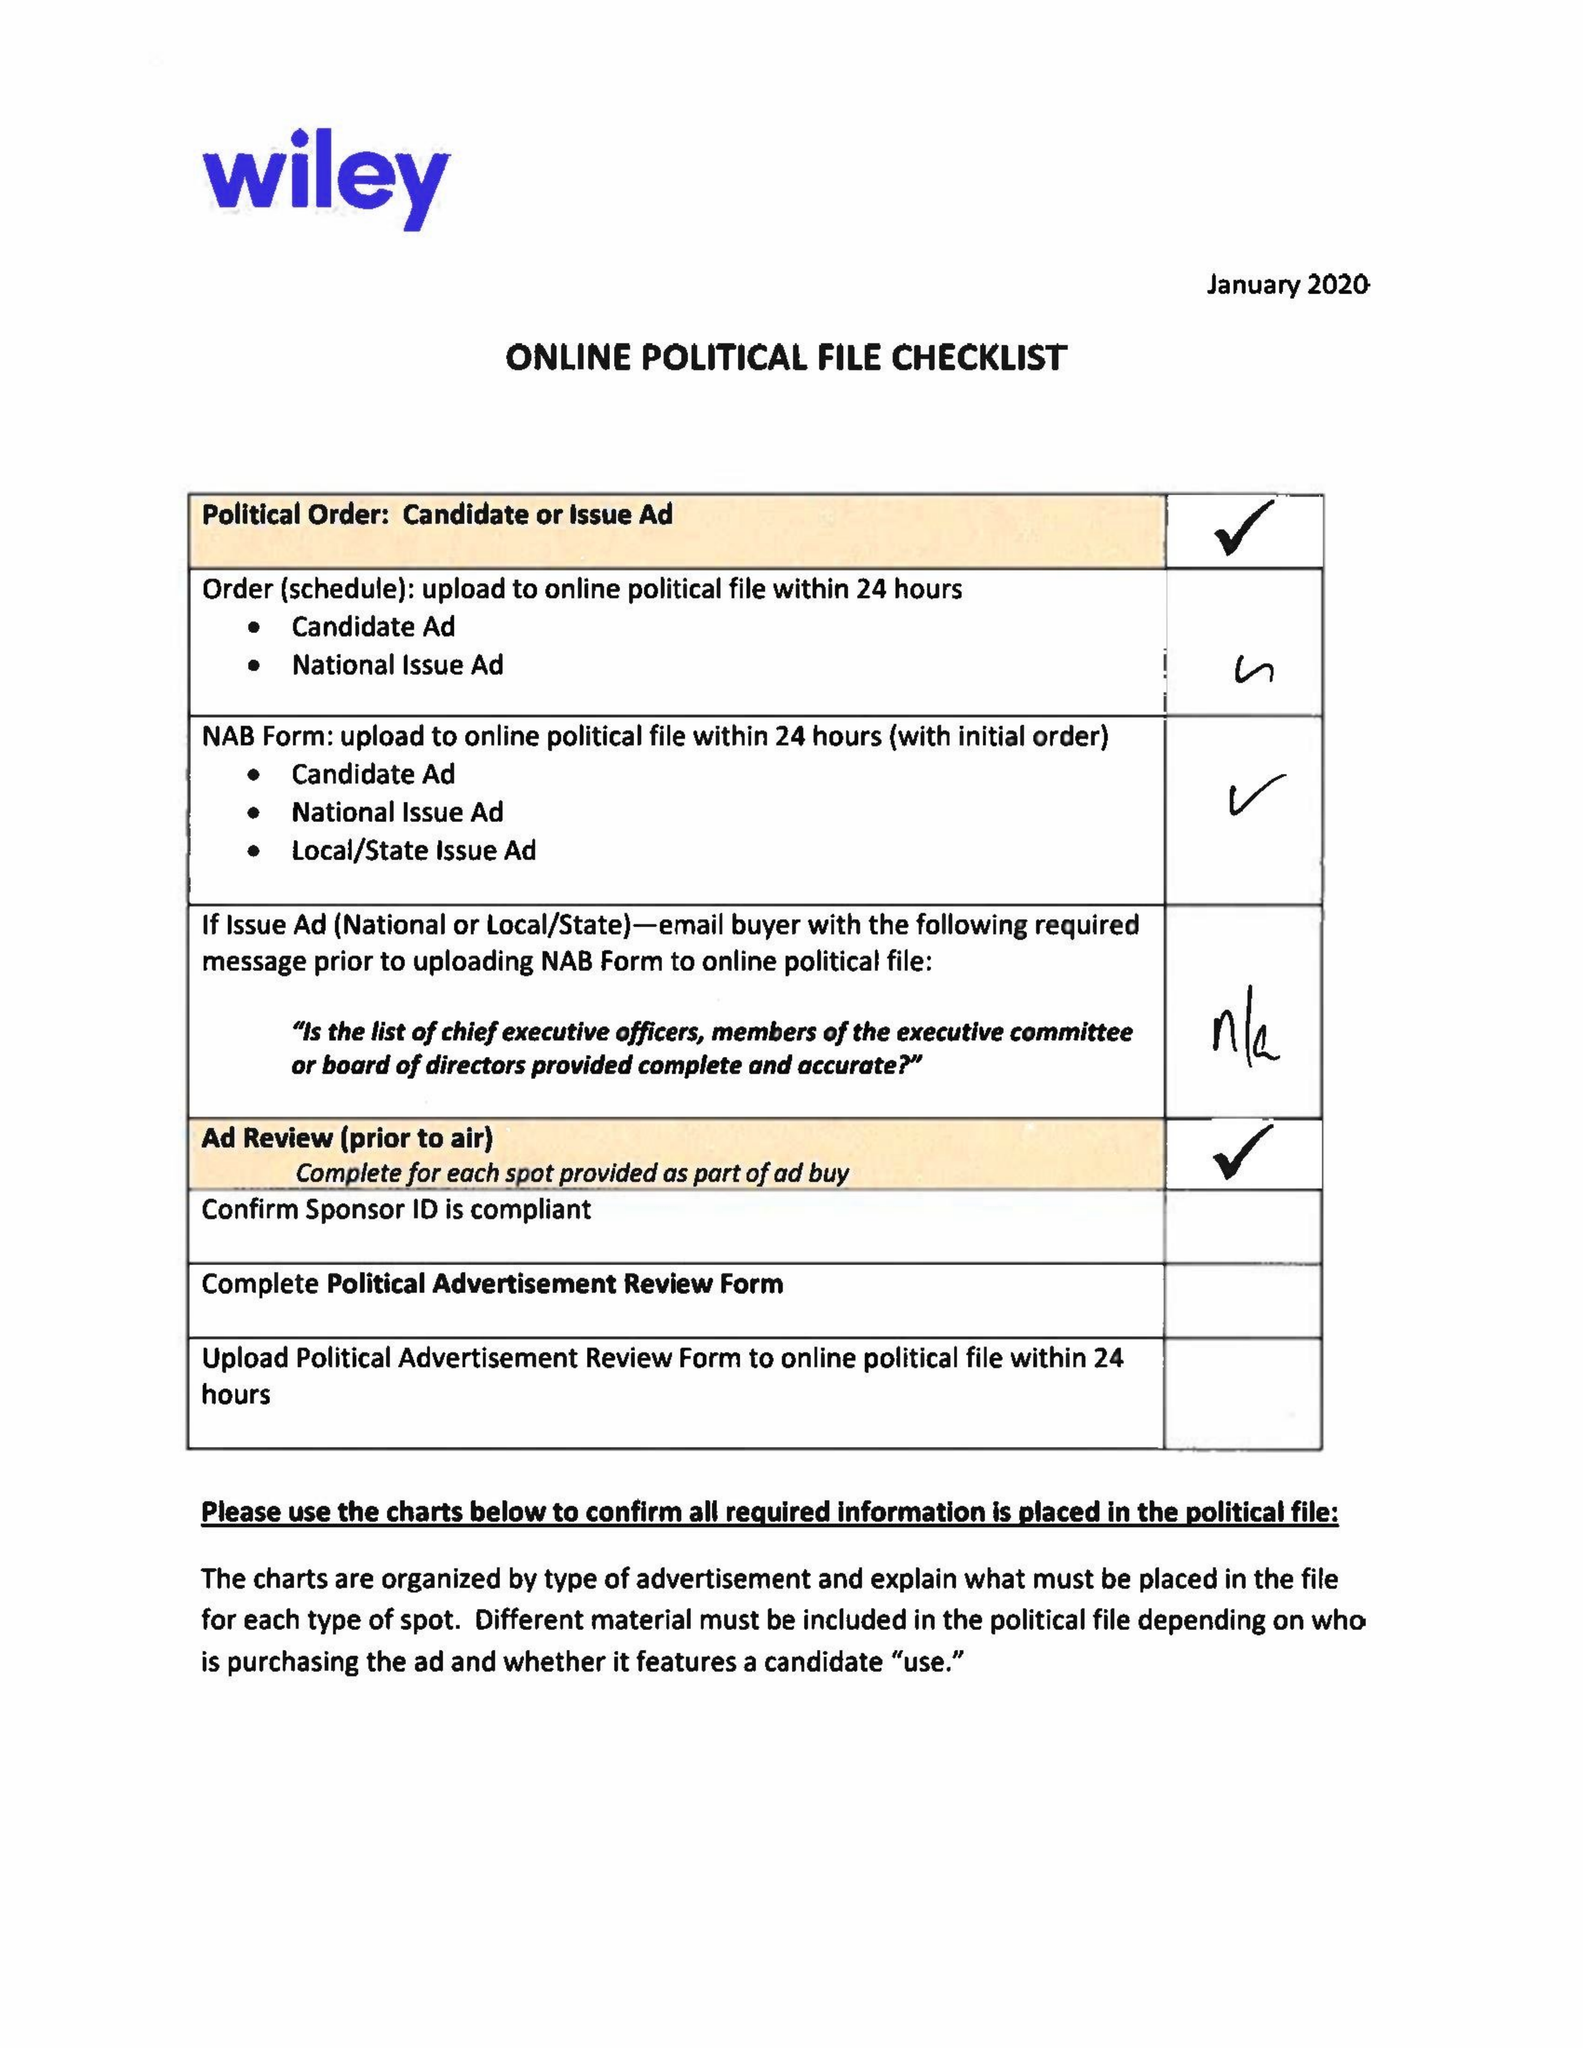What is the value for the gross_amount?
Answer the question using a single word or phrase. 4435.00 